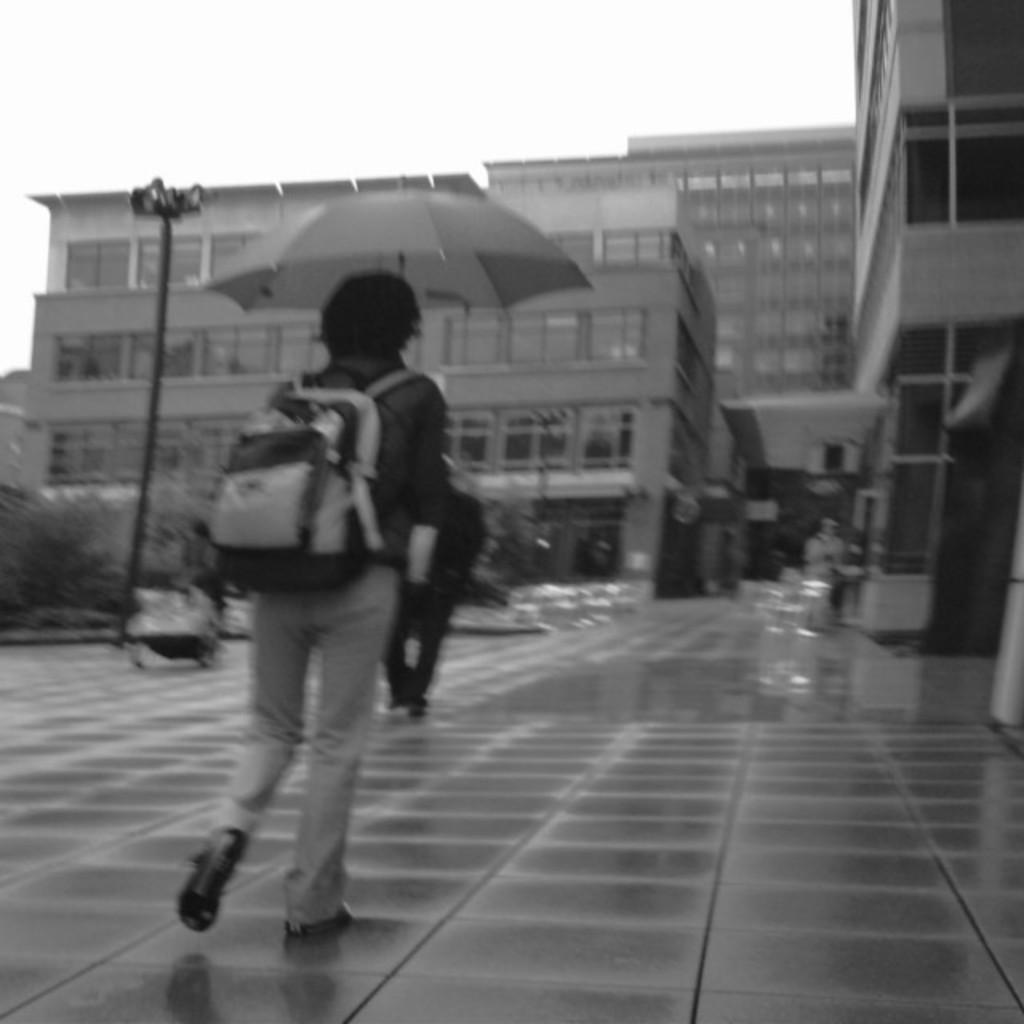Describe this image in one or two sentences. In this image I can see the buildings with windows. To the side of the building I can see few people walking and one person wearing the bag. I can see the pole and an umbrella to the left. And there is a sky in the background. 